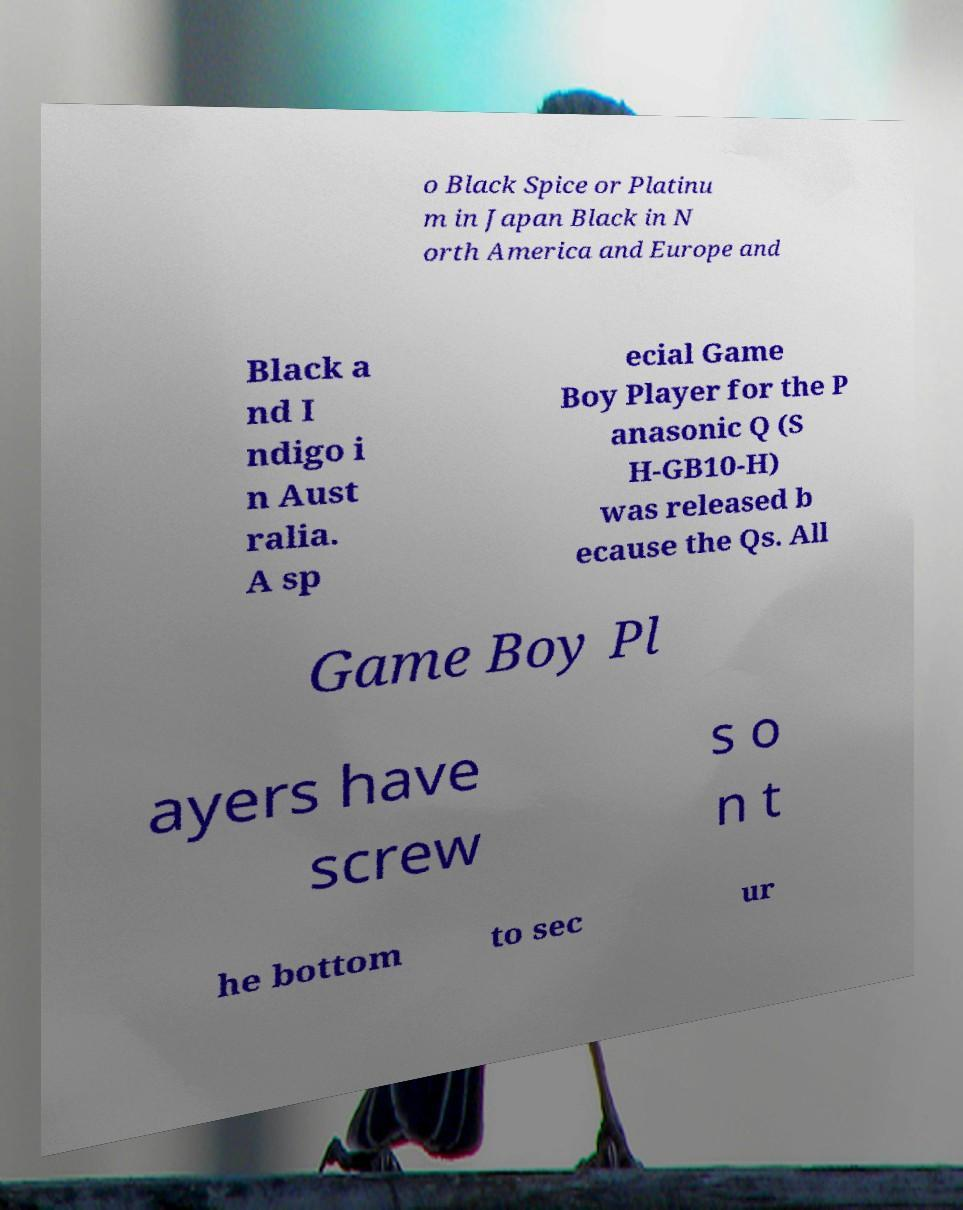What messages or text are displayed in this image? I need them in a readable, typed format. o Black Spice or Platinu m in Japan Black in N orth America and Europe and Black a nd I ndigo i n Aust ralia. A sp ecial Game Boy Player for the P anasonic Q (S H-GB10-H) was released b ecause the Qs. All Game Boy Pl ayers have screw s o n t he bottom to sec ur 